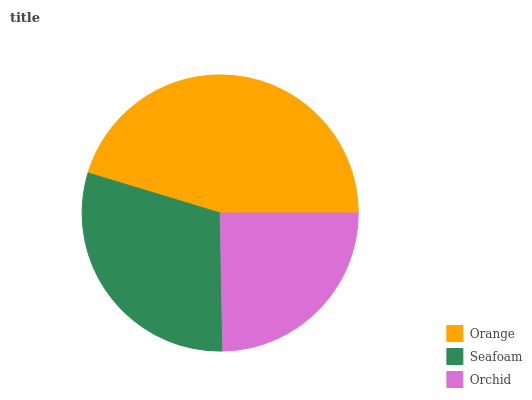Is Orchid the minimum?
Answer yes or no. Yes. Is Orange the maximum?
Answer yes or no. Yes. Is Seafoam the minimum?
Answer yes or no. No. Is Seafoam the maximum?
Answer yes or no. No. Is Orange greater than Seafoam?
Answer yes or no. Yes. Is Seafoam less than Orange?
Answer yes or no. Yes. Is Seafoam greater than Orange?
Answer yes or no. No. Is Orange less than Seafoam?
Answer yes or no. No. Is Seafoam the high median?
Answer yes or no. Yes. Is Seafoam the low median?
Answer yes or no. Yes. Is Orchid the high median?
Answer yes or no. No. Is Orchid the low median?
Answer yes or no. No. 